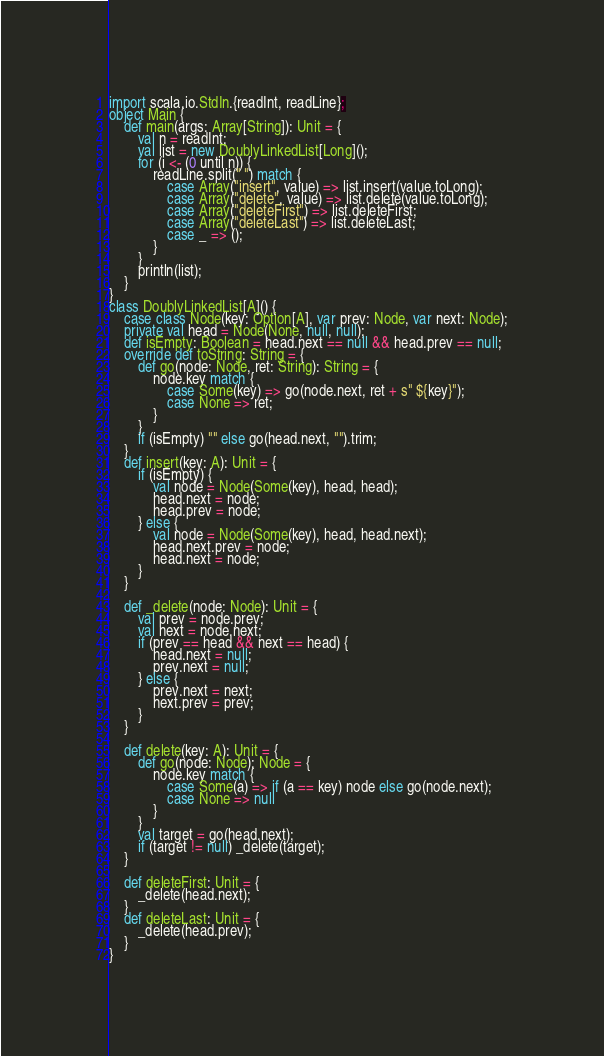<code> <loc_0><loc_0><loc_500><loc_500><_Scala_>import scala.io.StdIn.{readInt, readLine};
object Main {
    def main(args: Array[String]): Unit = {
        val n = readInt;
        val list = new DoublyLinkedList[Long]();
        for (i <- (0 until n)) {
            readLine.split(" ") match {
                case Array("insert", value) => list.insert(value.toLong);
                case Array("delete", value) => list.delete(value.toLong);
                case Array("deleteFirst") => list.deleteFirst;
                case Array("deleteLast") => list.deleteLast;
                case _ => ();
            }
        }
        println(list);
    }
}
class DoublyLinkedList[A]() {
    case class Node(key: Option[A], var prev: Node, var next: Node);
    private val head = Node(None, null, null);
    def isEmpty: Boolean = head.next == null && head.prev == null;
    override def toString: String = {
        def go(node: Node, ret: String): String = {
            node.key match {
                case Some(key) => go(node.next, ret + s" ${key}");
                case None => ret;
            }
        }
        if (isEmpty) "" else go(head.next, "").trim;
    }
    def insert(key: A): Unit = {
        if (isEmpty) {
            val node = Node(Some(key), head, head);
            head.next = node;
            head.prev = node;
        } else {
            val node = Node(Some(key), head, head.next);
            head.next.prev = node;
            head.next = node;
        }
    }
    
    def _delete(node: Node): Unit = {
        val prev = node.prev;
        val next = node.next;
        if (prev == head && next == head) {
            head.next = null;
            prev.next = null;
        } else {
            prev.next = next;
            next.prev = prev;
        }
    }
    
    def delete(key: A): Unit = {
        def go(node: Node): Node = {
            node.key match {
                case Some(a) => if (a == key) node else go(node.next);
                case None => null
            }
        }
        val target = go(head.next);
        if (target != null) _delete(target);
    }
    
    def deleteFirst: Unit = {
        _delete(head.next);
    }
    def deleteLast: Unit = {
        _delete(head.prev);
    }
}
</code> 